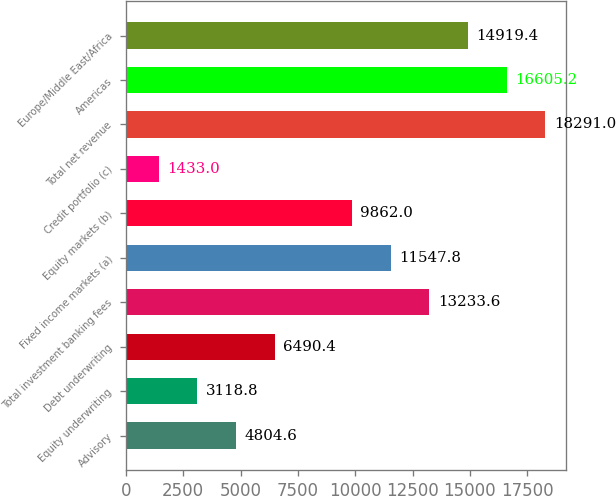Convert chart to OTSL. <chart><loc_0><loc_0><loc_500><loc_500><bar_chart><fcel>Advisory<fcel>Equity underwriting<fcel>Debt underwriting<fcel>Total investment banking fees<fcel>Fixed income markets (a)<fcel>Equity markets (b)<fcel>Credit portfolio (c)<fcel>Total net revenue<fcel>Americas<fcel>Europe/Middle East/Africa<nl><fcel>4804.6<fcel>3118.8<fcel>6490.4<fcel>13233.6<fcel>11547.8<fcel>9862<fcel>1433<fcel>18291<fcel>16605.2<fcel>14919.4<nl></chart> 